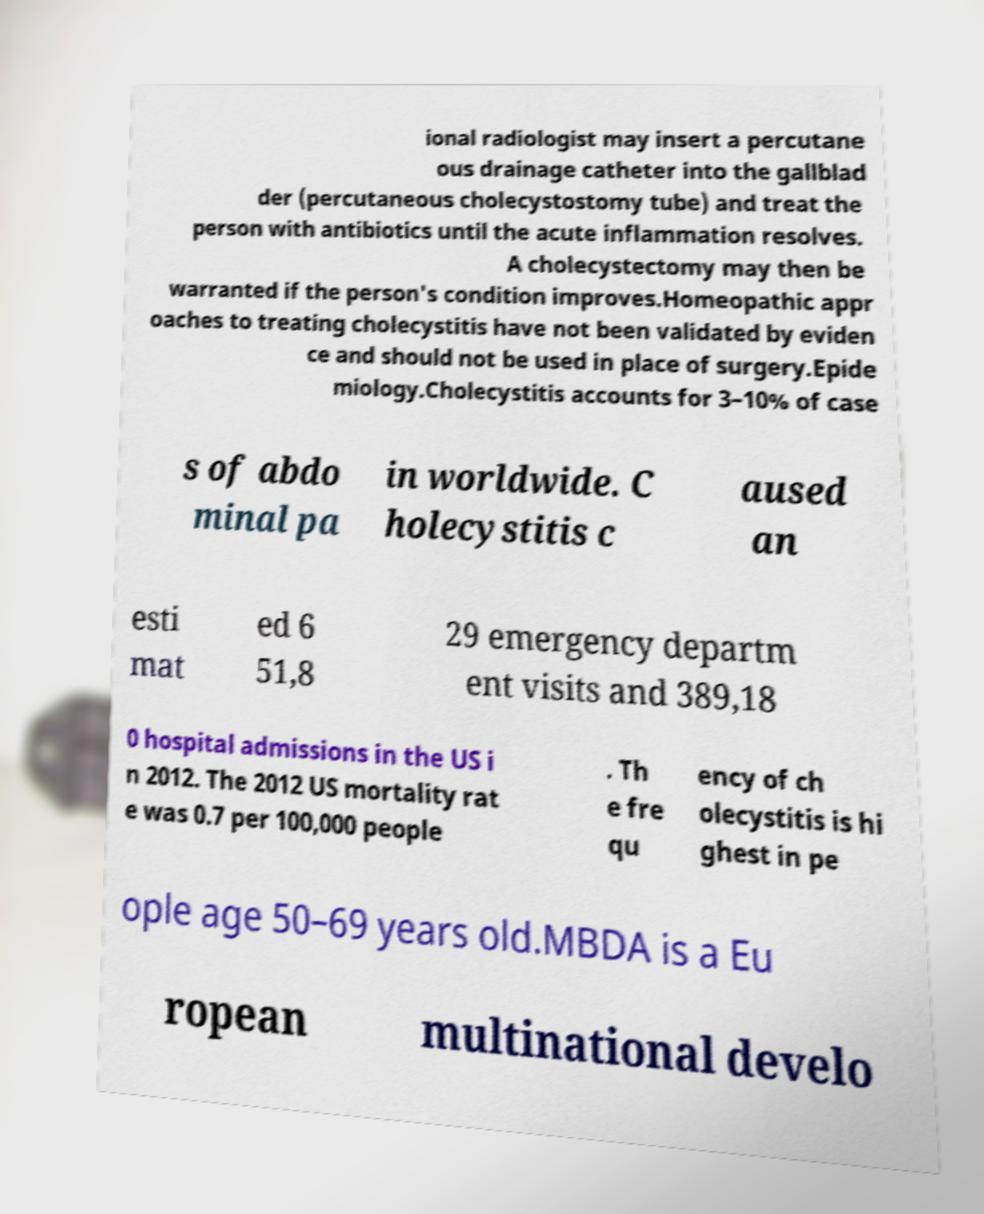There's text embedded in this image that I need extracted. Can you transcribe it verbatim? ional radiologist may insert a percutane ous drainage catheter into the gallblad der (percutaneous cholecystostomy tube) and treat the person with antibiotics until the acute inflammation resolves. A cholecystectomy may then be warranted if the person's condition improves.Homeopathic appr oaches to treating cholecystitis have not been validated by eviden ce and should not be used in place of surgery.Epide miology.Cholecystitis accounts for 3–10% of case s of abdo minal pa in worldwide. C holecystitis c aused an esti mat ed 6 51,8 29 emergency departm ent visits and 389,18 0 hospital admissions in the US i n 2012. The 2012 US mortality rat e was 0.7 per 100,000 people . Th e fre qu ency of ch olecystitis is hi ghest in pe ople age 50–69 years old.MBDA is a Eu ropean multinational develo 